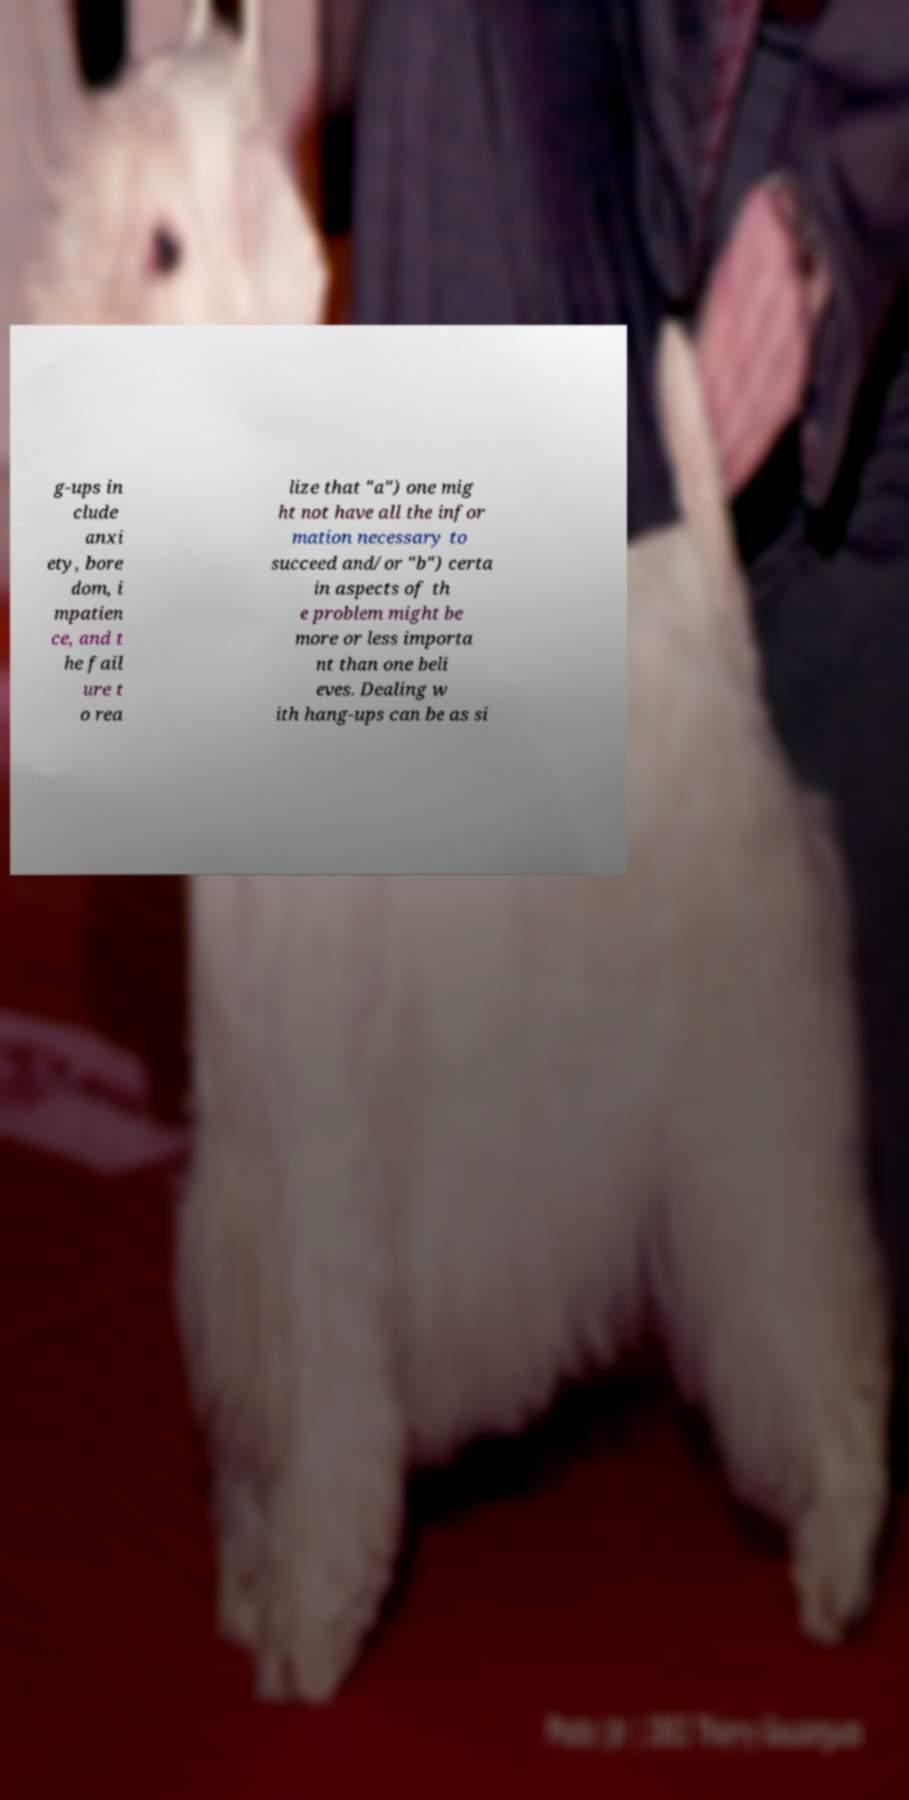Could you assist in decoding the text presented in this image and type it out clearly? g-ups in clude anxi ety, bore dom, i mpatien ce, and t he fail ure t o rea lize that "a") one mig ht not have all the infor mation necessary to succeed and/or "b") certa in aspects of th e problem might be more or less importa nt than one beli eves. Dealing w ith hang-ups can be as si 